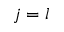<formula> <loc_0><loc_0><loc_500><loc_500>j = l</formula> 